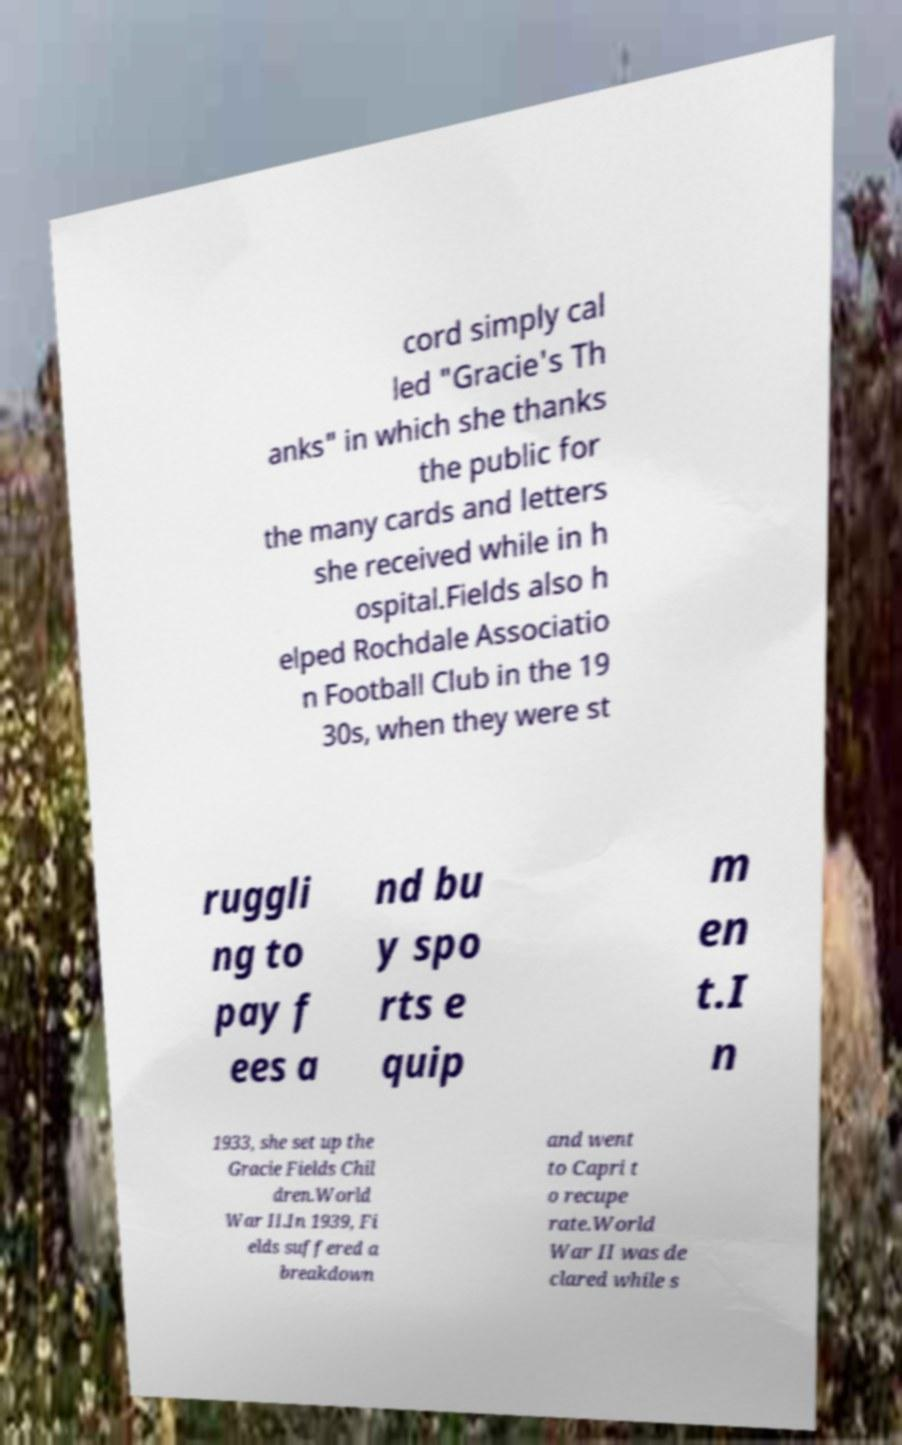I need the written content from this picture converted into text. Can you do that? cord simply cal led "Gracie's Th anks" in which she thanks the public for the many cards and letters she received while in h ospital.Fields also h elped Rochdale Associatio n Football Club in the 19 30s, when they were st ruggli ng to pay f ees a nd bu y spo rts e quip m en t.I n 1933, she set up the Gracie Fields Chil dren.World War II.In 1939, Fi elds suffered a breakdown and went to Capri t o recupe rate.World War II was de clared while s 